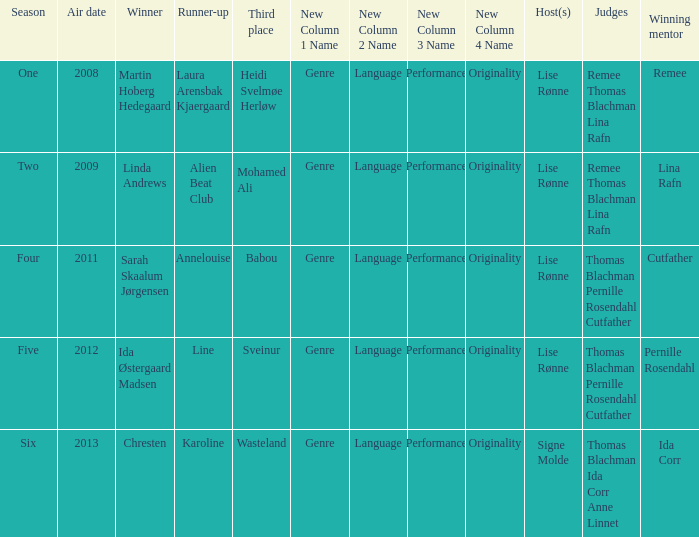Who was the winning mentor in season two? Lina Rafn. 